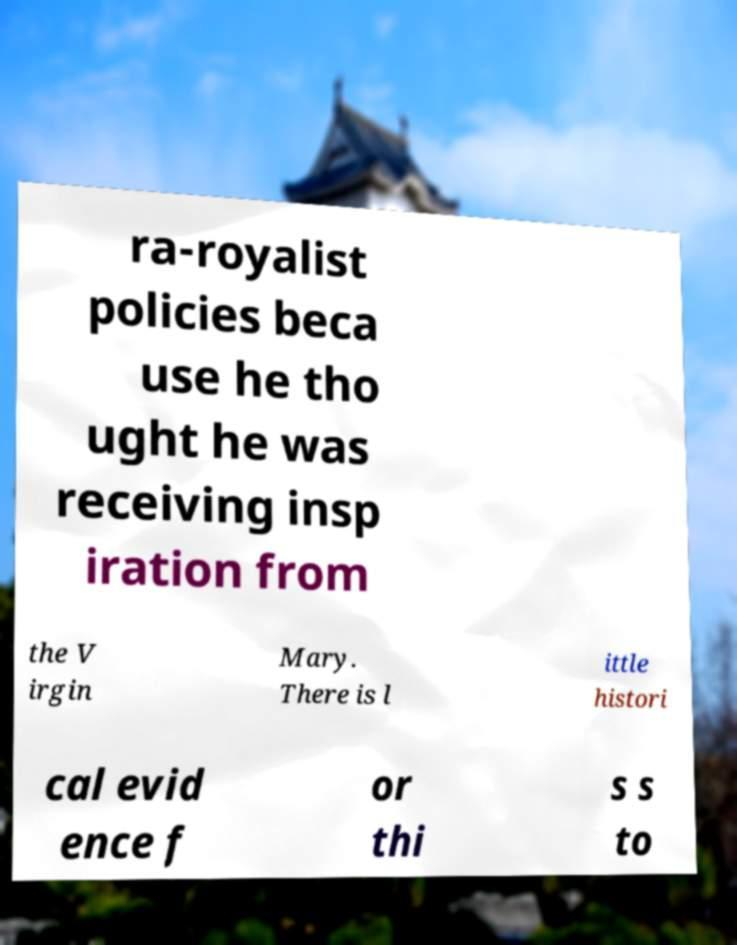Can you accurately transcribe the text from the provided image for me? ra-royalist policies beca use he tho ught he was receiving insp iration from the V irgin Mary. There is l ittle histori cal evid ence f or thi s s to 